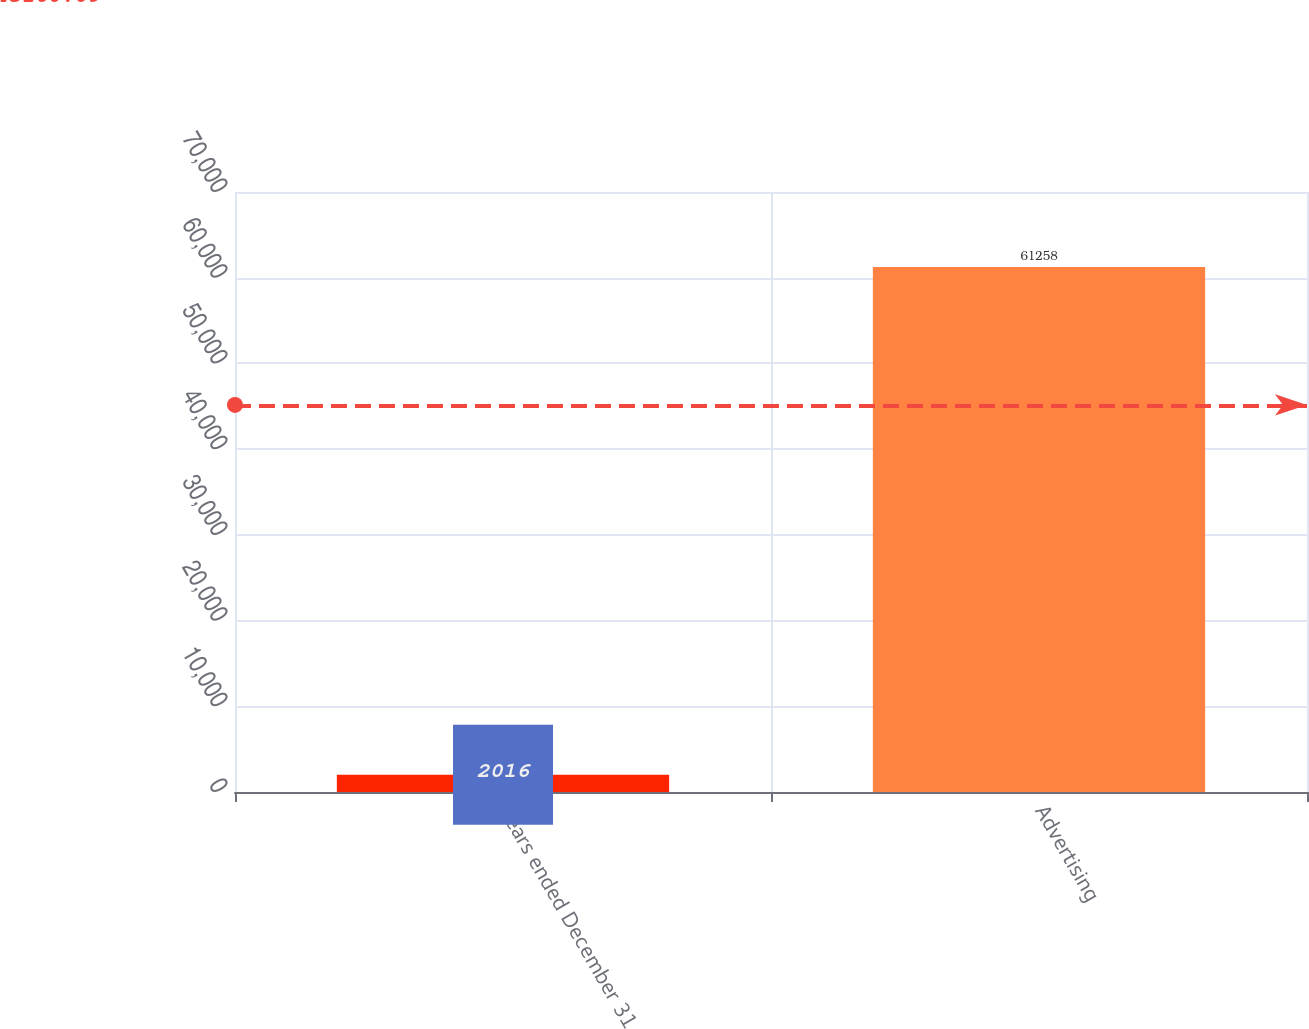<chart> <loc_0><loc_0><loc_500><loc_500><bar_chart><fcel>Years ended December 31<fcel>Advertising<nl><fcel>2016<fcel>61258<nl></chart> 